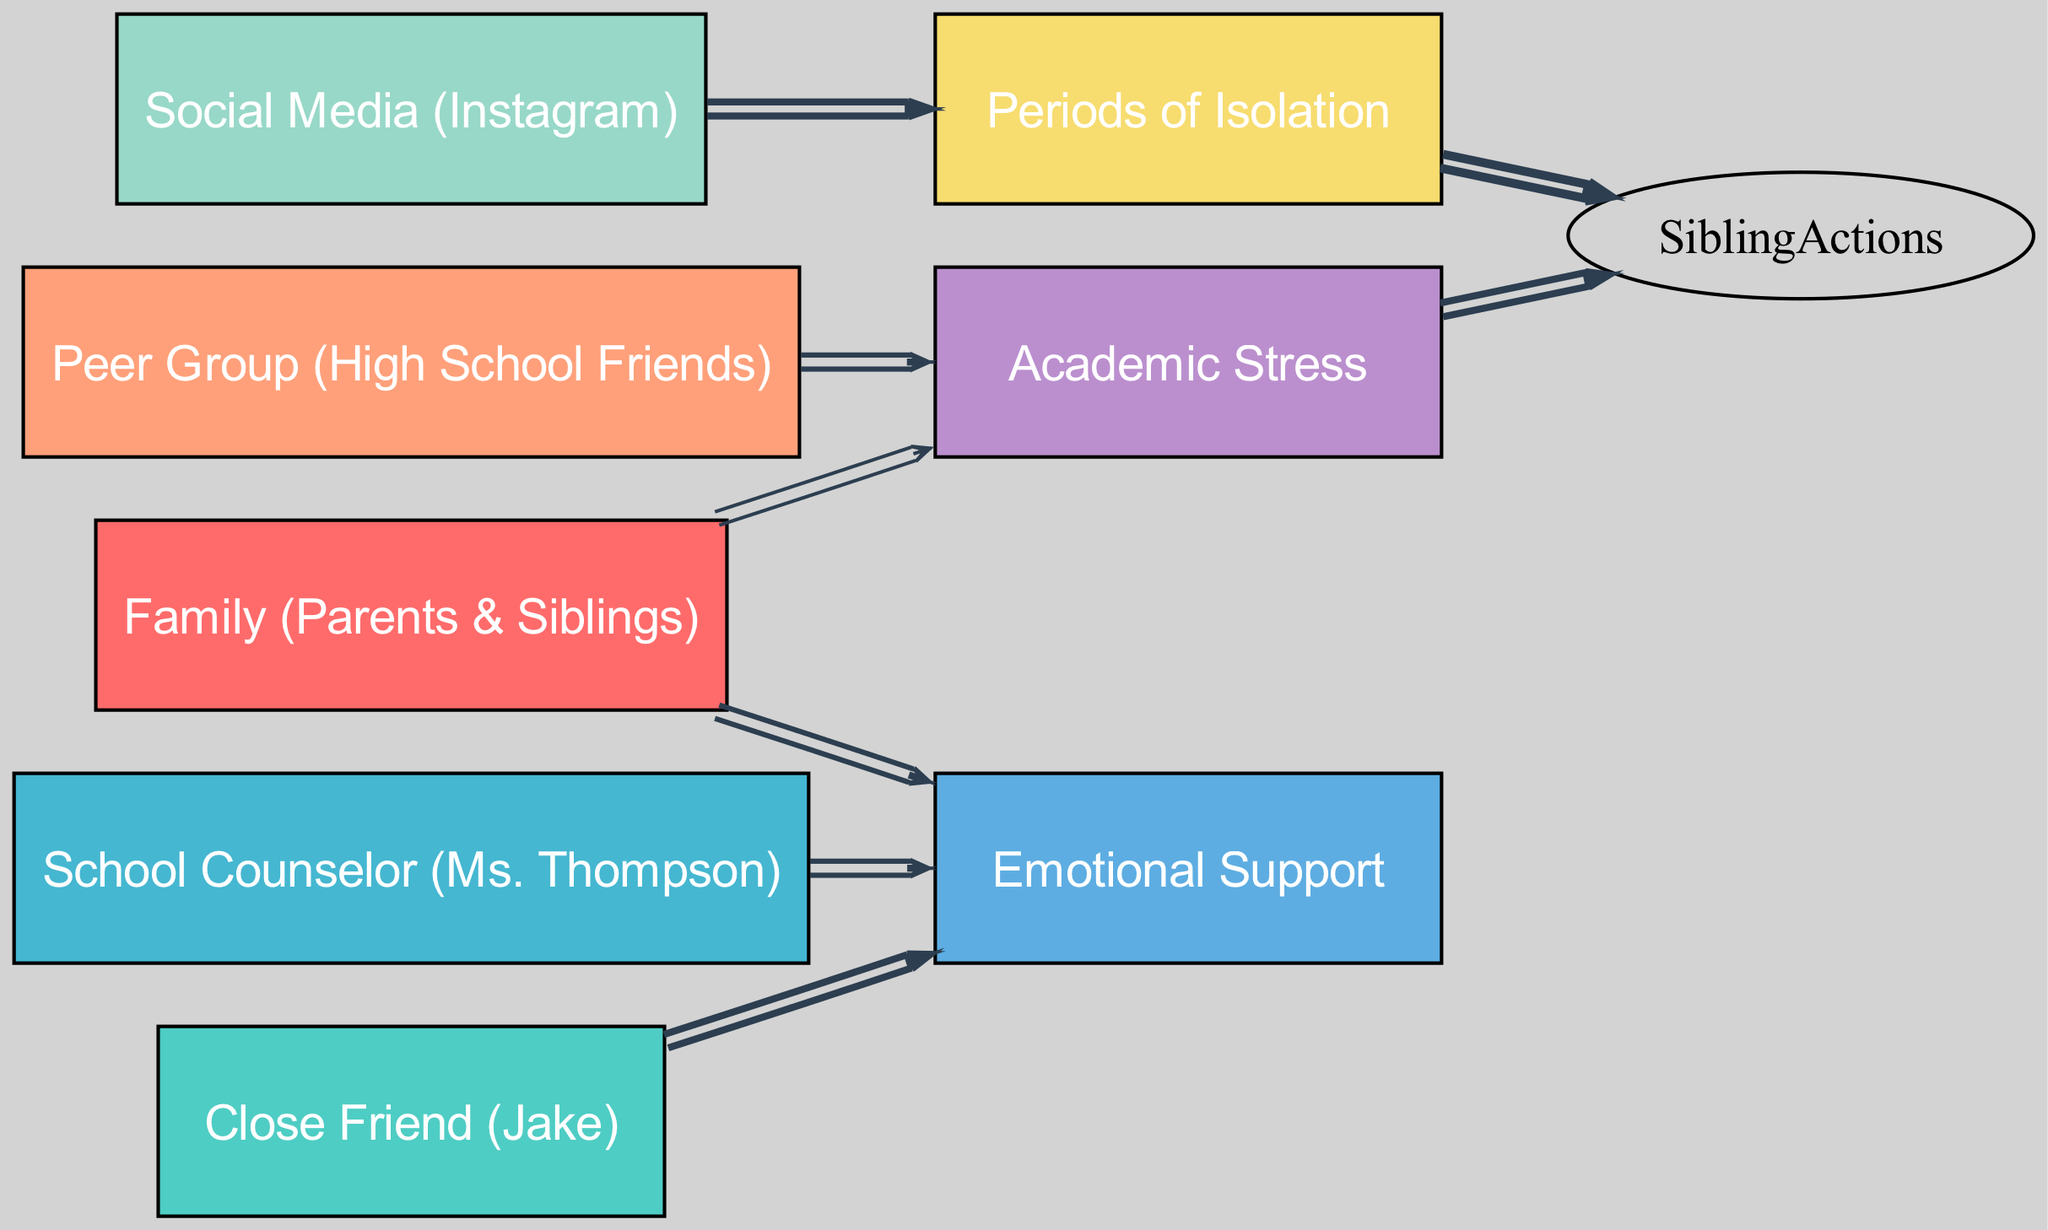What is the total number of nodes in the diagram? The diagram lists eight unique entities: Family, Close Friend, Counselor, Peer Group, Social Media, Isolation, Stress, and Emotional Support. Counting these gives a total of eight nodes.
Answer: 8 How many interactions lead to Emotional Support? The links leading to Emotional Support come from Family (3), Close Friend (4), and Counselor (3). Adding these values together results in 10 interactions.
Answer: 10 Which node has the highest flow leading to Sibling Actions? The link showing the highest flow to Sibling Actions comes from Isolation, with a value of 5. Comparing this with the flow from Stress (4), Isolation is clearly the node with the highest flow.
Answer: Isolation What is the relationship between Social Media and Isolation? The diagram shows a link from Social Media to Isolation with a flow value of 4, indicating that Social Media contributes significantly towards periods of Isolation.
Answer: 4 Which source contributes the most to Emotional Support? The Close Friend node contributes the most to Emotional Support, with a value of 4. This is higher than contributions from Family (3) and Counselor (3).
Answer: Close Friend What is the combined value of interactions from Stress and Isolation to Sibling Actions? Adding the interactions to Sibling Actions from Stress (4) and Isolation (5) gives a combined value of 9. Therefore, the total contribution from these two sources is 9.
Answer: 9 How does Emotional Support flow from Family compared to Close Friend? Emotional Support flows from Family at a value of 3 and from Close Friend at a value of 4. Thus, Close Friend provides more support than Family by 1.
Answer: Higher from Close Friend How many nodes contribute to Stress? Examining the diagram, there are two nodes that contribute to Stress: Family (2) and Peer Group (3). Therefore, there are two contributors to Stress.
Answer: 2 What are the two primary factors leading to Sibling Actions? The two primary factors leading to Sibling Actions are Isolation (5) and Stress (4). Isolation has the highest flow, followed by Stress, leading to a significant impact on Sibling Actions.
Answer: Isolation and Stress 